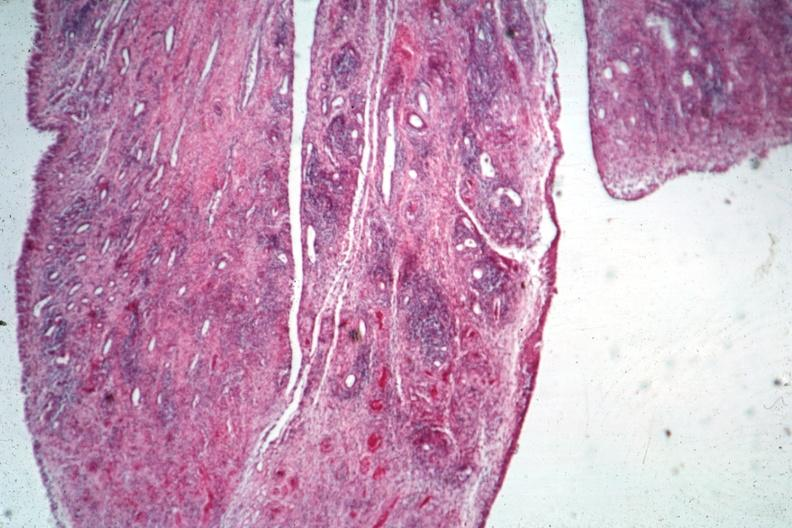s joints present?
Answer the question using a single word or phrase. Yes 